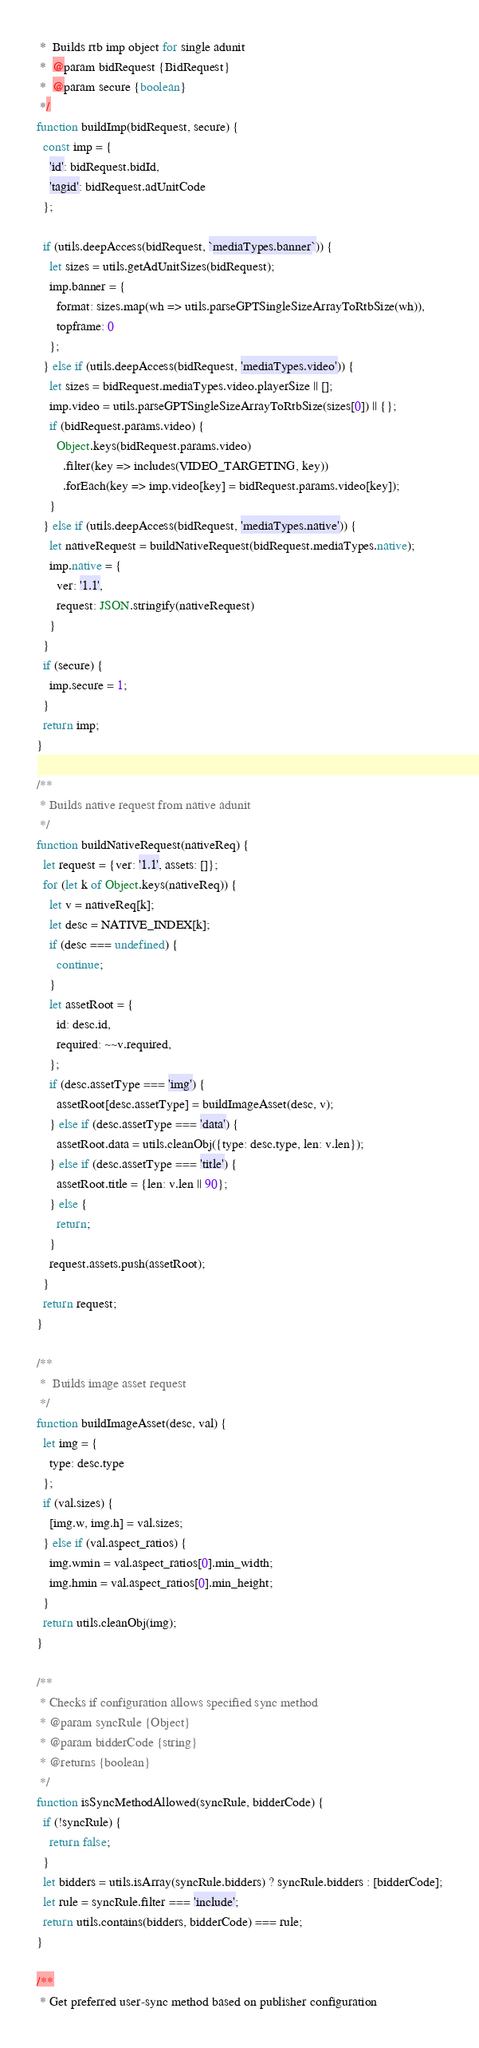<code> <loc_0><loc_0><loc_500><loc_500><_JavaScript_> *  Builds rtb imp object for single adunit
 *  @param bidRequest {BidRequest}
 *  @param secure {boolean}
 */
function buildImp(bidRequest, secure) {
  const imp = {
    'id': bidRequest.bidId,
    'tagid': bidRequest.adUnitCode
  };

  if (utils.deepAccess(bidRequest, `mediaTypes.banner`)) {
    let sizes = utils.getAdUnitSizes(bidRequest);
    imp.banner = {
      format: sizes.map(wh => utils.parseGPTSingleSizeArrayToRtbSize(wh)),
      topframe: 0
    };
  } else if (utils.deepAccess(bidRequest, 'mediaTypes.video')) {
    let sizes = bidRequest.mediaTypes.video.playerSize || [];
    imp.video = utils.parseGPTSingleSizeArrayToRtbSize(sizes[0]) || {};
    if (bidRequest.params.video) {
      Object.keys(bidRequest.params.video)
        .filter(key => includes(VIDEO_TARGETING, key))
        .forEach(key => imp.video[key] = bidRequest.params.video[key]);
    }
  } else if (utils.deepAccess(bidRequest, 'mediaTypes.native')) {
    let nativeRequest = buildNativeRequest(bidRequest.mediaTypes.native);
    imp.native = {
      ver: '1.1',
      request: JSON.stringify(nativeRequest)
    }
  }
  if (secure) {
    imp.secure = 1;
  }
  return imp;
}

/**
 * Builds native request from native adunit
 */
function buildNativeRequest(nativeReq) {
  let request = {ver: '1.1', assets: []};
  for (let k of Object.keys(nativeReq)) {
    let v = nativeReq[k];
    let desc = NATIVE_INDEX[k];
    if (desc === undefined) {
      continue;
    }
    let assetRoot = {
      id: desc.id,
      required: ~~v.required,
    };
    if (desc.assetType === 'img') {
      assetRoot[desc.assetType] = buildImageAsset(desc, v);
    } else if (desc.assetType === 'data') {
      assetRoot.data = utils.cleanObj({type: desc.type, len: v.len});
    } else if (desc.assetType === 'title') {
      assetRoot.title = {len: v.len || 90};
    } else {
      return;
    }
    request.assets.push(assetRoot);
  }
  return request;
}

/**
 *  Builds image asset request
 */
function buildImageAsset(desc, val) {
  let img = {
    type: desc.type
  };
  if (val.sizes) {
    [img.w, img.h] = val.sizes;
  } else if (val.aspect_ratios) {
    img.wmin = val.aspect_ratios[0].min_width;
    img.hmin = val.aspect_ratios[0].min_height;
  }
  return utils.cleanObj(img);
}

/**
 * Checks if configuration allows specified sync method
 * @param syncRule {Object}
 * @param bidderCode {string}
 * @returns {boolean}
 */
function isSyncMethodAllowed(syncRule, bidderCode) {
  if (!syncRule) {
    return false;
  }
  let bidders = utils.isArray(syncRule.bidders) ? syncRule.bidders : [bidderCode];
  let rule = syncRule.filter === 'include';
  return utils.contains(bidders, bidderCode) === rule;
}

/**
 * Get preferred user-sync method based on publisher configuration</code> 